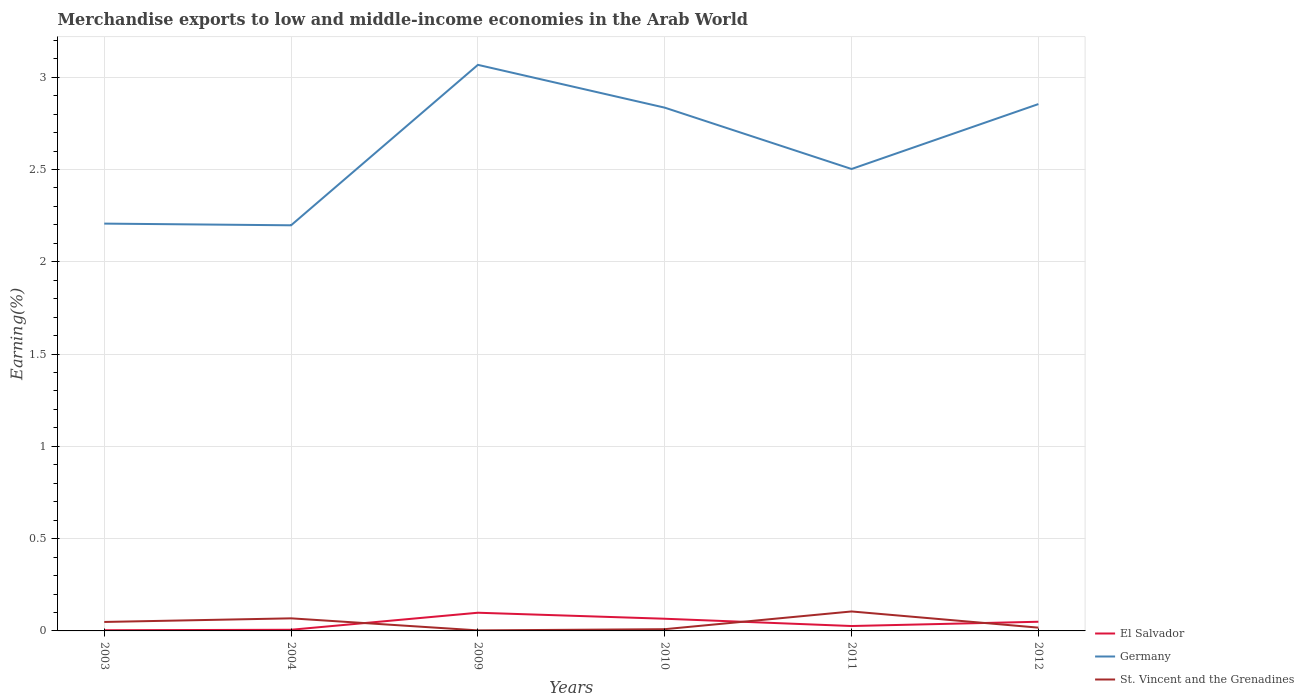Is the number of lines equal to the number of legend labels?
Give a very brief answer. Yes. Across all years, what is the maximum percentage of amount earned from merchandise exports in Germany?
Your answer should be compact. 2.2. What is the total percentage of amount earned from merchandise exports in El Salvador in the graph?
Provide a short and direct response. 0.03. What is the difference between the highest and the second highest percentage of amount earned from merchandise exports in El Salvador?
Your answer should be compact. 0.09. How many lines are there?
Give a very brief answer. 3. How many years are there in the graph?
Provide a succinct answer. 6. Are the values on the major ticks of Y-axis written in scientific E-notation?
Ensure brevity in your answer.  No. Where does the legend appear in the graph?
Your response must be concise. Bottom right. How are the legend labels stacked?
Provide a succinct answer. Vertical. What is the title of the graph?
Your answer should be compact. Merchandise exports to low and middle-income economies in the Arab World. What is the label or title of the Y-axis?
Ensure brevity in your answer.  Earning(%). What is the Earning(%) in El Salvador in 2003?
Provide a short and direct response. 0. What is the Earning(%) in Germany in 2003?
Ensure brevity in your answer.  2.21. What is the Earning(%) of St. Vincent and the Grenadines in 2003?
Offer a terse response. 0.05. What is the Earning(%) of El Salvador in 2004?
Provide a succinct answer. 0.01. What is the Earning(%) in Germany in 2004?
Make the answer very short. 2.2. What is the Earning(%) of St. Vincent and the Grenadines in 2004?
Your answer should be very brief. 0.07. What is the Earning(%) in El Salvador in 2009?
Your response must be concise. 0.1. What is the Earning(%) of Germany in 2009?
Ensure brevity in your answer.  3.07. What is the Earning(%) in St. Vincent and the Grenadines in 2009?
Provide a succinct answer. 0. What is the Earning(%) in El Salvador in 2010?
Make the answer very short. 0.07. What is the Earning(%) of Germany in 2010?
Make the answer very short. 2.84. What is the Earning(%) in St. Vincent and the Grenadines in 2010?
Make the answer very short. 0.01. What is the Earning(%) in El Salvador in 2011?
Provide a short and direct response. 0.03. What is the Earning(%) of Germany in 2011?
Make the answer very short. 2.5. What is the Earning(%) in St. Vincent and the Grenadines in 2011?
Make the answer very short. 0.11. What is the Earning(%) of El Salvador in 2012?
Provide a succinct answer. 0.05. What is the Earning(%) in Germany in 2012?
Provide a succinct answer. 2.85. What is the Earning(%) in St. Vincent and the Grenadines in 2012?
Your answer should be compact. 0.02. Across all years, what is the maximum Earning(%) in El Salvador?
Offer a very short reply. 0.1. Across all years, what is the maximum Earning(%) of Germany?
Make the answer very short. 3.07. Across all years, what is the maximum Earning(%) of St. Vincent and the Grenadines?
Give a very brief answer. 0.11. Across all years, what is the minimum Earning(%) in El Salvador?
Your answer should be very brief. 0. Across all years, what is the minimum Earning(%) in Germany?
Provide a short and direct response. 2.2. Across all years, what is the minimum Earning(%) in St. Vincent and the Grenadines?
Keep it short and to the point. 0. What is the total Earning(%) of El Salvador in the graph?
Provide a succinct answer. 0.25. What is the total Earning(%) of Germany in the graph?
Your answer should be very brief. 15.66. What is the total Earning(%) of St. Vincent and the Grenadines in the graph?
Provide a succinct answer. 0.25. What is the difference between the Earning(%) of El Salvador in 2003 and that in 2004?
Your answer should be very brief. -0. What is the difference between the Earning(%) of Germany in 2003 and that in 2004?
Offer a very short reply. 0.01. What is the difference between the Earning(%) in St. Vincent and the Grenadines in 2003 and that in 2004?
Ensure brevity in your answer.  -0.02. What is the difference between the Earning(%) of El Salvador in 2003 and that in 2009?
Your response must be concise. -0.09. What is the difference between the Earning(%) of Germany in 2003 and that in 2009?
Your response must be concise. -0.86. What is the difference between the Earning(%) in St. Vincent and the Grenadines in 2003 and that in 2009?
Your answer should be compact. 0.05. What is the difference between the Earning(%) in El Salvador in 2003 and that in 2010?
Your response must be concise. -0.06. What is the difference between the Earning(%) of Germany in 2003 and that in 2010?
Make the answer very short. -0.63. What is the difference between the Earning(%) in St. Vincent and the Grenadines in 2003 and that in 2010?
Offer a terse response. 0.04. What is the difference between the Earning(%) of El Salvador in 2003 and that in 2011?
Ensure brevity in your answer.  -0.02. What is the difference between the Earning(%) in Germany in 2003 and that in 2011?
Your answer should be compact. -0.3. What is the difference between the Earning(%) of St. Vincent and the Grenadines in 2003 and that in 2011?
Make the answer very short. -0.06. What is the difference between the Earning(%) of El Salvador in 2003 and that in 2012?
Keep it short and to the point. -0.05. What is the difference between the Earning(%) of Germany in 2003 and that in 2012?
Offer a very short reply. -0.65. What is the difference between the Earning(%) of St. Vincent and the Grenadines in 2003 and that in 2012?
Your response must be concise. 0.03. What is the difference between the Earning(%) in El Salvador in 2004 and that in 2009?
Make the answer very short. -0.09. What is the difference between the Earning(%) in Germany in 2004 and that in 2009?
Provide a succinct answer. -0.87. What is the difference between the Earning(%) of St. Vincent and the Grenadines in 2004 and that in 2009?
Ensure brevity in your answer.  0.07. What is the difference between the Earning(%) of El Salvador in 2004 and that in 2010?
Keep it short and to the point. -0.06. What is the difference between the Earning(%) in Germany in 2004 and that in 2010?
Give a very brief answer. -0.64. What is the difference between the Earning(%) in St. Vincent and the Grenadines in 2004 and that in 2010?
Give a very brief answer. 0.06. What is the difference between the Earning(%) in El Salvador in 2004 and that in 2011?
Make the answer very short. -0.02. What is the difference between the Earning(%) in Germany in 2004 and that in 2011?
Provide a short and direct response. -0.3. What is the difference between the Earning(%) in St. Vincent and the Grenadines in 2004 and that in 2011?
Offer a very short reply. -0.04. What is the difference between the Earning(%) of El Salvador in 2004 and that in 2012?
Provide a succinct answer. -0.04. What is the difference between the Earning(%) of Germany in 2004 and that in 2012?
Keep it short and to the point. -0.66. What is the difference between the Earning(%) of St. Vincent and the Grenadines in 2004 and that in 2012?
Your answer should be compact. 0.05. What is the difference between the Earning(%) in El Salvador in 2009 and that in 2010?
Offer a very short reply. 0.03. What is the difference between the Earning(%) in Germany in 2009 and that in 2010?
Your answer should be compact. 0.23. What is the difference between the Earning(%) in St. Vincent and the Grenadines in 2009 and that in 2010?
Ensure brevity in your answer.  -0.01. What is the difference between the Earning(%) of El Salvador in 2009 and that in 2011?
Offer a terse response. 0.07. What is the difference between the Earning(%) of Germany in 2009 and that in 2011?
Offer a very short reply. 0.56. What is the difference between the Earning(%) in St. Vincent and the Grenadines in 2009 and that in 2011?
Your answer should be compact. -0.1. What is the difference between the Earning(%) of El Salvador in 2009 and that in 2012?
Your answer should be very brief. 0.05. What is the difference between the Earning(%) of Germany in 2009 and that in 2012?
Your answer should be compact. 0.21. What is the difference between the Earning(%) in St. Vincent and the Grenadines in 2009 and that in 2012?
Offer a terse response. -0.01. What is the difference between the Earning(%) in El Salvador in 2010 and that in 2011?
Your answer should be compact. 0.04. What is the difference between the Earning(%) of Germany in 2010 and that in 2011?
Provide a short and direct response. 0.33. What is the difference between the Earning(%) of St. Vincent and the Grenadines in 2010 and that in 2011?
Your answer should be compact. -0.1. What is the difference between the Earning(%) in El Salvador in 2010 and that in 2012?
Your answer should be compact. 0.02. What is the difference between the Earning(%) of Germany in 2010 and that in 2012?
Make the answer very short. -0.02. What is the difference between the Earning(%) of St. Vincent and the Grenadines in 2010 and that in 2012?
Give a very brief answer. -0.01. What is the difference between the Earning(%) of El Salvador in 2011 and that in 2012?
Your answer should be compact. -0.02. What is the difference between the Earning(%) of Germany in 2011 and that in 2012?
Your answer should be compact. -0.35. What is the difference between the Earning(%) in St. Vincent and the Grenadines in 2011 and that in 2012?
Make the answer very short. 0.09. What is the difference between the Earning(%) in El Salvador in 2003 and the Earning(%) in Germany in 2004?
Your answer should be compact. -2.19. What is the difference between the Earning(%) of El Salvador in 2003 and the Earning(%) of St. Vincent and the Grenadines in 2004?
Keep it short and to the point. -0.06. What is the difference between the Earning(%) in Germany in 2003 and the Earning(%) in St. Vincent and the Grenadines in 2004?
Provide a succinct answer. 2.14. What is the difference between the Earning(%) of El Salvador in 2003 and the Earning(%) of Germany in 2009?
Make the answer very short. -3.06. What is the difference between the Earning(%) of El Salvador in 2003 and the Earning(%) of St. Vincent and the Grenadines in 2009?
Offer a terse response. 0. What is the difference between the Earning(%) in Germany in 2003 and the Earning(%) in St. Vincent and the Grenadines in 2009?
Provide a short and direct response. 2.2. What is the difference between the Earning(%) in El Salvador in 2003 and the Earning(%) in Germany in 2010?
Ensure brevity in your answer.  -2.83. What is the difference between the Earning(%) of El Salvador in 2003 and the Earning(%) of St. Vincent and the Grenadines in 2010?
Ensure brevity in your answer.  -0.01. What is the difference between the Earning(%) in Germany in 2003 and the Earning(%) in St. Vincent and the Grenadines in 2010?
Provide a succinct answer. 2.2. What is the difference between the Earning(%) of El Salvador in 2003 and the Earning(%) of Germany in 2011?
Your response must be concise. -2.5. What is the difference between the Earning(%) in El Salvador in 2003 and the Earning(%) in St. Vincent and the Grenadines in 2011?
Keep it short and to the point. -0.1. What is the difference between the Earning(%) of Germany in 2003 and the Earning(%) of St. Vincent and the Grenadines in 2011?
Offer a terse response. 2.1. What is the difference between the Earning(%) of El Salvador in 2003 and the Earning(%) of Germany in 2012?
Make the answer very short. -2.85. What is the difference between the Earning(%) in El Salvador in 2003 and the Earning(%) in St. Vincent and the Grenadines in 2012?
Provide a succinct answer. -0.01. What is the difference between the Earning(%) in Germany in 2003 and the Earning(%) in St. Vincent and the Grenadines in 2012?
Provide a succinct answer. 2.19. What is the difference between the Earning(%) in El Salvador in 2004 and the Earning(%) in Germany in 2009?
Give a very brief answer. -3.06. What is the difference between the Earning(%) of El Salvador in 2004 and the Earning(%) of St. Vincent and the Grenadines in 2009?
Offer a very short reply. 0. What is the difference between the Earning(%) of Germany in 2004 and the Earning(%) of St. Vincent and the Grenadines in 2009?
Provide a short and direct response. 2.19. What is the difference between the Earning(%) in El Salvador in 2004 and the Earning(%) in Germany in 2010?
Make the answer very short. -2.83. What is the difference between the Earning(%) in El Salvador in 2004 and the Earning(%) in St. Vincent and the Grenadines in 2010?
Provide a succinct answer. -0. What is the difference between the Earning(%) in Germany in 2004 and the Earning(%) in St. Vincent and the Grenadines in 2010?
Your answer should be compact. 2.19. What is the difference between the Earning(%) of El Salvador in 2004 and the Earning(%) of Germany in 2011?
Your response must be concise. -2.5. What is the difference between the Earning(%) in El Salvador in 2004 and the Earning(%) in St. Vincent and the Grenadines in 2011?
Your answer should be very brief. -0.1. What is the difference between the Earning(%) of Germany in 2004 and the Earning(%) of St. Vincent and the Grenadines in 2011?
Provide a short and direct response. 2.09. What is the difference between the Earning(%) in El Salvador in 2004 and the Earning(%) in Germany in 2012?
Your answer should be compact. -2.85. What is the difference between the Earning(%) in El Salvador in 2004 and the Earning(%) in St. Vincent and the Grenadines in 2012?
Keep it short and to the point. -0.01. What is the difference between the Earning(%) in Germany in 2004 and the Earning(%) in St. Vincent and the Grenadines in 2012?
Offer a terse response. 2.18. What is the difference between the Earning(%) of El Salvador in 2009 and the Earning(%) of Germany in 2010?
Your answer should be compact. -2.74. What is the difference between the Earning(%) of El Salvador in 2009 and the Earning(%) of St. Vincent and the Grenadines in 2010?
Make the answer very short. 0.09. What is the difference between the Earning(%) of Germany in 2009 and the Earning(%) of St. Vincent and the Grenadines in 2010?
Keep it short and to the point. 3.06. What is the difference between the Earning(%) of El Salvador in 2009 and the Earning(%) of Germany in 2011?
Keep it short and to the point. -2.4. What is the difference between the Earning(%) in El Salvador in 2009 and the Earning(%) in St. Vincent and the Grenadines in 2011?
Keep it short and to the point. -0.01. What is the difference between the Earning(%) in Germany in 2009 and the Earning(%) in St. Vincent and the Grenadines in 2011?
Your answer should be very brief. 2.96. What is the difference between the Earning(%) in El Salvador in 2009 and the Earning(%) in Germany in 2012?
Give a very brief answer. -2.76. What is the difference between the Earning(%) of El Salvador in 2009 and the Earning(%) of St. Vincent and the Grenadines in 2012?
Your answer should be very brief. 0.08. What is the difference between the Earning(%) in Germany in 2009 and the Earning(%) in St. Vincent and the Grenadines in 2012?
Your answer should be very brief. 3.05. What is the difference between the Earning(%) in El Salvador in 2010 and the Earning(%) in Germany in 2011?
Your answer should be compact. -2.44. What is the difference between the Earning(%) in El Salvador in 2010 and the Earning(%) in St. Vincent and the Grenadines in 2011?
Keep it short and to the point. -0.04. What is the difference between the Earning(%) of Germany in 2010 and the Earning(%) of St. Vincent and the Grenadines in 2011?
Keep it short and to the point. 2.73. What is the difference between the Earning(%) of El Salvador in 2010 and the Earning(%) of Germany in 2012?
Offer a terse response. -2.79. What is the difference between the Earning(%) in El Salvador in 2010 and the Earning(%) in St. Vincent and the Grenadines in 2012?
Your answer should be very brief. 0.05. What is the difference between the Earning(%) of Germany in 2010 and the Earning(%) of St. Vincent and the Grenadines in 2012?
Your answer should be compact. 2.82. What is the difference between the Earning(%) in El Salvador in 2011 and the Earning(%) in Germany in 2012?
Keep it short and to the point. -2.83. What is the difference between the Earning(%) of El Salvador in 2011 and the Earning(%) of St. Vincent and the Grenadines in 2012?
Provide a succinct answer. 0.01. What is the difference between the Earning(%) of Germany in 2011 and the Earning(%) of St. Vincent and the Grenadines in 2012?
Keep it short and to the point. 2.48. What is the average Earning(%) in El Salvador per year?
Your response must be concise. 0.04. What is the average Earning(%) in Germany per year?
Ensure brevity in your answer.  2.61. What is the average Earning(%) of St. Vincent and the Grenadines per year?
Your response must be concise. 0.04. In the year 2003, what is the difference between the Earning(%) of El Salvador and Earning(%) of Germany?
Offer a terse response. -2.2. In the year 2003, what is the difference between the Earning(%) in El Salvador and Earning(%) in St. Vincent and the Grenadines?
Ensure brevity in your answer.  -0.04. In the year 2003, what is the difference between the Earning(%) in Germany and Earning(%) in St. Vincent and the Grenadines?
Provide a succinct answer. 2.16. In the year 2004, what is the difference between the Earning(%) in El Salvador and Earning(%) in Germany?
Offer a terse response. -2.19. In the year 2004, what is the difference between the Earning(%) in El Salvador and Earning(%) in St. Vincent and the Grenadines?
Your answer should be very brief. -0.06. In the year 2004, what is the difference between the Earning(%) in Germany and Earning(%) in St. Vincent and the Grenadines?
Keep it short and to the point. 2.13. In the year 2009, what is the difference between the Earning(%) of El Salvador and Earning(%) of Germany?
Offer a very short reply. -2.97. In the year 2009, what is the difference between the Earning(%) of El Salvador and Earning(%) of St. Vincent and the Grenadines?
Ensure brevity in your answer.  0.1. In the year 2009, what is the difference between the Earning(%) in Germany and Earning(%) in St. Vincent and the Grenadines?
Your answer should be very brief. 3.06. In the year 2010, what is the difference between the Earning(%) in El Salvador and Earning(%) in Germany?
Offer a terse response. -2.77. In the year 2010, what is the difference between the Earning(%) of El Salvador and Earning(%) of St. Vincent and the Grenadines?
Your answer should be compact. 0.06. In the year 2010, what is the difference between the Earning(%) in Germany and Earning(%) in St. Vincent and the Grenadines?
Offer a terse response. 2.83. In the year 2011, what is the difference between the Earning(%) of El Salvador and Earning(%) of Germany?
Make the answer very short. -2.48. In the year 2011, what is the difference between the Earning(%) of El Salvador and Earning(%) of St. Vincent and the Grenadines?
Ensure brevity in your answer.  -0.08. In the year 2011, what is the difference between the Earning(%) of Germany and Earning(%) of St. Vincent and the Grenadines?
Keep it short and to the point. 2.4. In the year 2012, what is the difference between the Earning(%) of El Salvador and Earning(%) of Germany?
Offer a very short reply. -2.8. In the year 2012, what is the difference between the Earning(%) in El Salvador and Earning(%) in St. Vincent and the Grenadines?
Your answer should be compact. 0.03. In the year 2012, what is the difference between the Earning(%) of Germany and Earning(%) of St. Vincent and the Grenadines?
Provide a short and direct response. 2.84. What is the ratio of the Earning(%) in El Salvador in 2003 to that in 2004?
Give a very brief answer. 0.58. What is the ratio of the Earning(%) in Germany in 2003 to that in 2004?
Your answer should be compact. 1. What is the ratio of the Earning(%) of St. Vincent and the Grenadines in 2003 to that in 2004?
Your answer should be very brief. 0.71. What is the ratio of the Earning(%) in El Salvador in 2003 to that in 2009?
Make the answer very short. 0.04. What is the ratio of the Earning(%) in Germany in 2003 to that in 2009?
Keep it short and to the point. 0.72. What is the ratio of the Earning(%) in St. Vincent and the Grenadines in 2003 to that in 2009?
Keep it short and to the point. 16.76. What is the ratio of the Earning(%) of El Salvador in 2003 to that in 2010?
Provide a short and direct response. 0.06. What is the ratio of the Earning(%) in Germany in 2003 to that in 2010?
Give a very brief answer. 0.78. What is the ratio of the Earning(%) in St. Vincent and the Grenadines in 2003 to that in 2010?
Provide a succinct answer. 5.16. What is the ratio of the Earning(%) of El Salvador in 2003 to that in 2011?
Provide a short and direct response. 0.14. What is the ratio of the Earning(%) in Germany in 2003 to that in 2011?
Make the answer very short. 0.88. What is the ratio of the Earning(%) of St. Vincent and the Grenadines in 2003 to that in 2011?
Keep it short and to the point. 0.46. What is the ratio of the Earning(%) in El Salvador in 2003 to that in 2012?
Provide a succinct answer. 0.07. What is the ratio of the Earning(%) in Germany in 2003 to that in 2012?
Offer a very short reply. 0.77. What is the ratio of the Earning(%) in St. Vincent and the Grenadines in 2003 to that in 2012?
Give a very brief answer. 2.74. What is the ratio of the Earning(%) in El Salvador in 2004 to that in 2009?
Keep it short and to the point. 0.06. What is the ratio of the Earning(%) in Germany in 2004 to that in 2009?
Provide a short and direct response. 0.72. What is the ratio of the Earning(%) of St. Vincent and the Grenadines in 2004 to that in 2009?
Your answer should be very brief. 23.51. What is the ratio of the Earning(%) in El Salvador in 2004 to that in 2010?
Give a very brief answer. 0.1. What is the ratio of the Earning(%) of Germany in 2004 to that in 2010?
Offer a very short reply. 0.78. What is the ratio of the Earning(%) in St. Vincent and the Grenadines in 2004 to that in 2010?
Make the answer very short. 7.24. What is the ratio of the Earning(%) of El Salvador in 2004 to that in 2011?
Provide a short and direct response. 0.24. What is the ratio of the Earning(%) of Germany in 2004 to that in 2011?
Make the answer very short. 0.88. What is the ratio of the Earning(%) in St. Vincent and the Grenadines in 2004 to that in 2011?
Offer a very short reply. 0.65. What is the ratio of the Earning(%) of El Salvador in 2004 to that in 2012?
Provide a short and direct response. 0.13. What is the ratio of the Earning(%) of Germany in 2004 to that in 2012?
Offer a terse response. 0.77. What is the ratio of the Earning(%) of St. Vincent and the Grenadines in 2004 to that in 2012?
Ensure brevity in your answer.  3.84. What is the ratio of the Earning(%) in El Salvador in 2009 to that in 2010?
Provide a short and direct response. 1.49. What is the ratio of the Earning(%) in Germany in 2009 to that in 2010?
Provide a succinct answer. 1.08. What is the ratio of the Earning(%) in St. Vincent and the Grenadines in 2009 to that in 2010?
Provide a short and direct response. 0.31. What is the ratio of the Earning(%) in El Salvador in 2009 to that in 2011?
Ensure brevity in your answer.  3.71. What is the ratio of the Earning(%) in Germany in 2009 to that in 2011?
Your answer should be very brief. 1.23. What is the ratio of the Earning(%) of St. Vincent and the Grenadines in 2009 to that in 2011?
Your answer should be very brief. 0.03. What is the ratio of the Earning(%) of El Salvador in 2009 to that in 2012?
Provide a short and direct response. 1.98. What is the ratio of the Earning(%) in Germany in 2009 to that in 2012?
Make the answer very short. 1.07. What is the ratio of the Earning(%) in St. Vincent and the Grenadines in 2009 to that in 2012?
Your answer should be very brief. 0.16. What is the ratio of the Earning(%) of El Salvador in 2010 to that in 2011?
Your answer should be compact. 2.49. What is the ratio of the Earning(%) in Germany in 2010 to that in 2011?
Provide a succinct answer. 1.13. What is the ratio of the Earning(%) in St. Vincent and the Grenadines in 2010 to that in 2011?
Give a very brief answer. 0.09. What is the ratio of the Earning(%) of El Salvador in 2010 to that in 2012?
Make the answer very short. 1.33. What is the ratio of the Earning(%) of St. Vincent and the Grenadines in 2010 to that in 2012?
Your response must be concise. 0.53. What is the ratio of the Earning(%) in El Salvador in 2011 to that in 2012?
Give a very brief answer. 0.53. What is the ratio of the Earning(%) of Germany in 2011 to that in 2012?
Provide a short and direct response. 0.88. What is the ratio of the Earning(%) in St. Vincent and the Grenadines in 2011 to that in 2012?
Your answer should be very brief. 5.94. What is the difference between the highest and the second highest Earning(%) of El Salvador?
Your answer should be compact. 0.03. What is the difference between the highest and the second highest Earning(%) of Germany?
Offer a very short reply. 0.21. What is the difference between the highest and the second highest Earning(%) of St. Vincent and the Grenadines?
Make the answer very short. 0.04. What is the difference between the highest and the lowest Earning(%) in El Salvador?
Provide a short and direct response. 0.09. What is the difference between the highest and the lowest Earning(%) in Germany?
Offer a very short reply. 0.87. What is the difference between the highest and the lowest Earning(%) of St. Vincent and the Grenadines?
Offer a terse response. 0.1. 